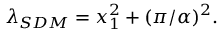<formula> <loc_0><loc_0><loc_500><loc_500>\lambda _ { S D M } = x _ { 1 } ^ { 2 } + ( \pi / \alpha ) ^ { 2 } .</formula> 